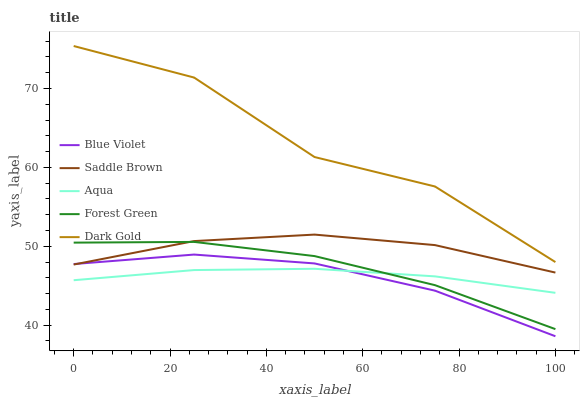Does Blue Violet have the minimum area under the curve?
Answer yes or no. Yes. Does Dark Gold have the maximum area under the curve?
Answer yes or no. Yes. Does Aqua have the minimum area under the curve?
Answer yes or no. No. Does Aqua have the maximum area under the curve?
Answer yes or no. No. Is Aqua the smoothest?
Answer yes or no. Yes. Is Dark Gold the roughest?
Answer yes or no. Yes. Is Saddle Brown the smoothest?
Answer yes or no. No. Is Saddle Brown the roughest?
Answer yes or no. No. Does Blue Violet have the lowest value?
Answer yes or no. Yes. Does Aqua have the lowest value?
Answer yes or no. No. Does Dark Gold have the highest value?
Answer yes or no. Yes. Does Saddle Brown have the highest value?
Answer yes or no. No. Is Forest Green less than Dark Gold?
Answer yes or no. Yes. Is Dark Gold greater than Forest Green?
Answer yes or no. Yes. Does Forest Green intersect Aqua?
Answer yes or no. Yes. Is Forest Green less than Aqua?
Answer yes or no. No. Is Forest Green greater than Aqua?
Answer yes or no. No. Does Forest Green intersect Dark Gold?
Answer yes or no. No. 